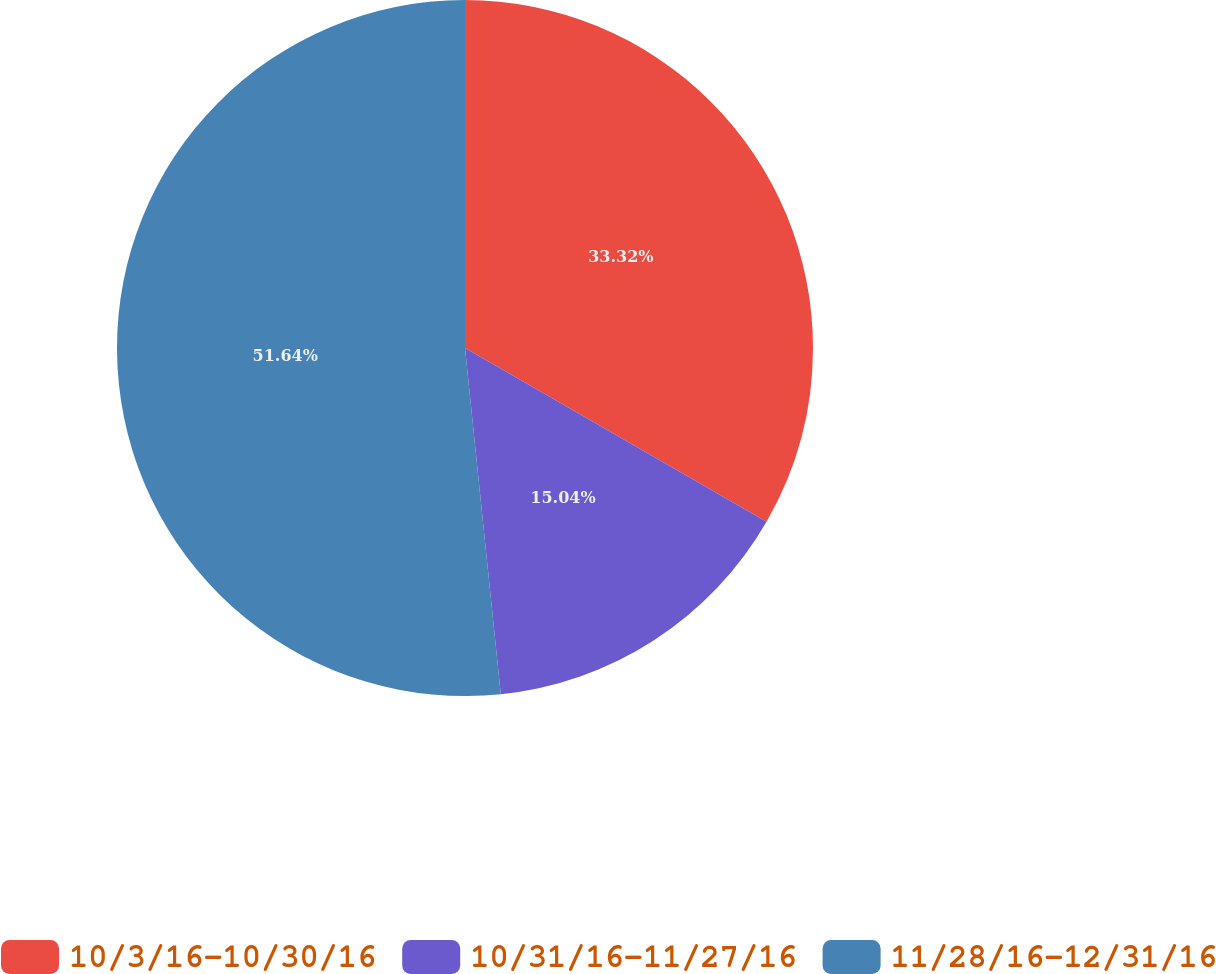Convert chart to OTSL. <chart><loc_0><loc_0><loc_500><loc_500><pie_chart><fcel>10/3/16-10/30/16<fcel>10/31/16-11/27/16<fcel>11/28/16-12/31/16<nl><fcel>33.32%<fcel>15.04%<fcel>51.64%<nl></chart> 